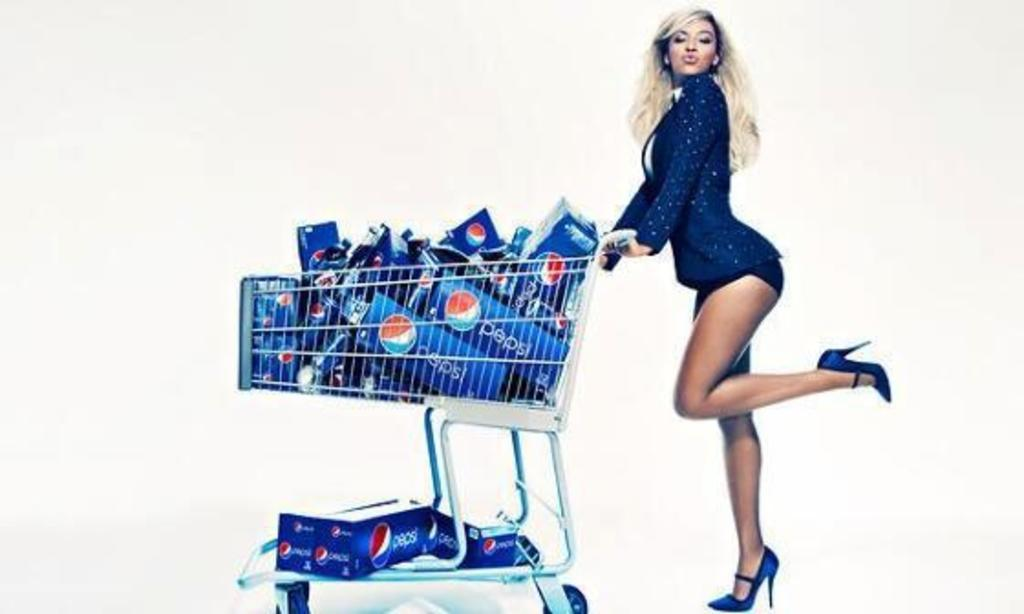Who is the main subject in the image? There is a girl in the image. What is the girl holding in the image? The girl is holding a cart in the image. What can be found inside the cart? There are bottles in the cart. What flavor of ice cream are the girl's friends enjoying in the image? There is no ice cream or friends present in the image. 